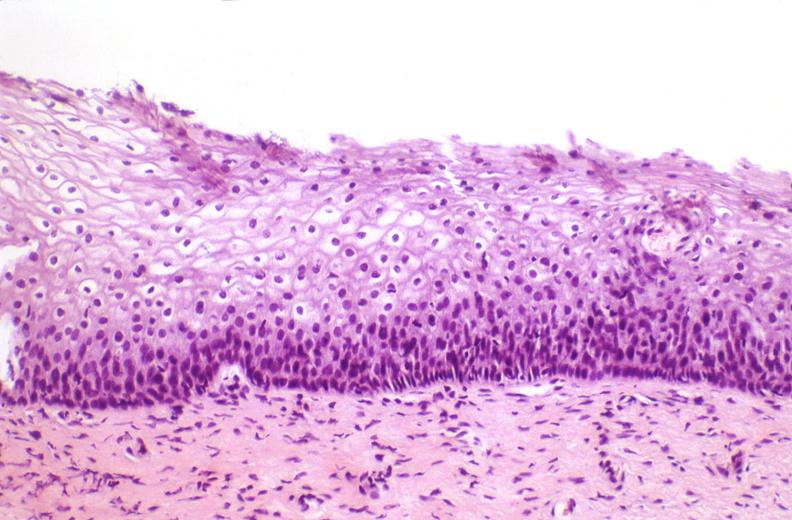s cytomegalovirus present?
Answer the question using a single word or phrase. No 